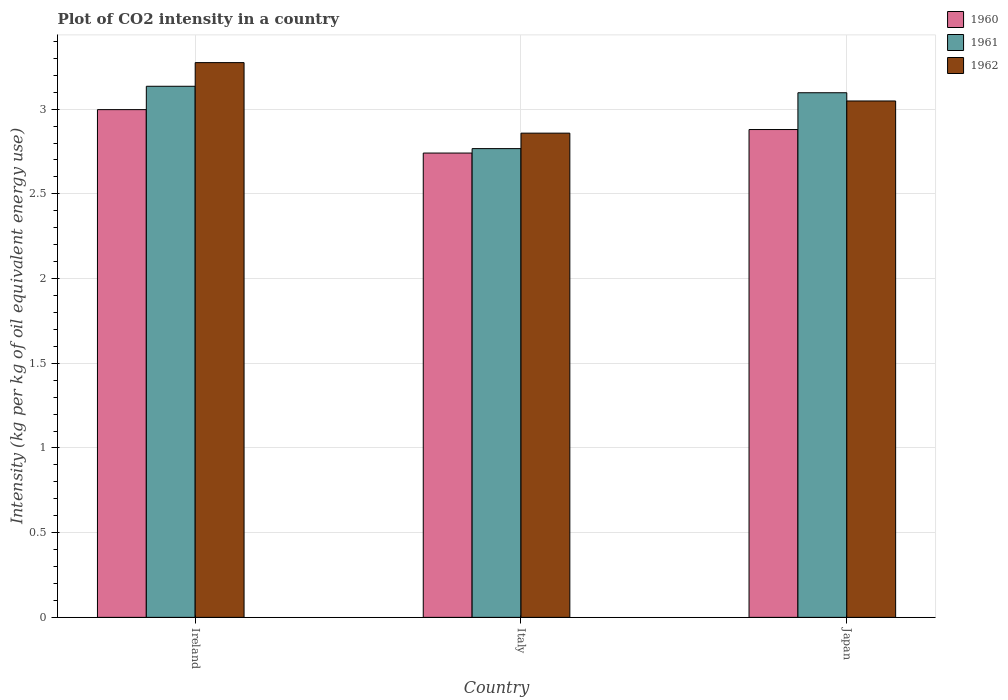How many different coloured bars are there?
Your answer should be very brief. 3. How many groups of bars are there?
Make the answer very short. 3. Are the number of bars per tick equal to the number of legend labels?
Keep it short and to the point. Yes. How many bars are there on the 3rd tick from the right?
Offer a very short reply. 3. What is the label of the 1st group of bars from the left?
Your answer should be compact. Ireland. In how many cases, is the number of bars for a given country not equal to the number of legend labels?
Offer a very short reply. 0. What is the CO2 intensity in in 1961 in Italy?
Keep it short and to the point. 2.77. Across all countries, what is the maximum CO2 intensity in in 1961?
Your response must be concise. 3.14. Across all countries, what is the minimum CO2 intensity in in 1960?
Ensure brevity in your answer.  2.74. In which country was the CO2 intensity in in 1960 maximum?
Your answer should be very brief. Ireland. In which country was the CO2 intensity in in 1961 minimum?
Ensure brevity in your answer.  Italy. What is the total CO2 intensity in in 1962 in the graph?
Ensure brevity in your answer.  9.18. What is the difference between the CO2 intensity in in 1960 in Ireland and that in Japan?
Ensure brevity in your answer.  0.12. What is the difference between the CO2 intensity in in 1960 in Ireland and the CO2 intensity in in 1962 in Italy?
Offer a very short reply. 0.14. What is the average CO2 intensity in in 1960 per country?
Offer a very short reply. 2.87. What is the difference between the CO2 intensity in of/in 1961 and CO2 intensity in of/in 1962 in Italy?
Ensure brevity in your answer.  -0.09. In how many countries, is the CO2 intensity in in 1961 greater than 1.8 kg?
Make the answer very short. 3. What is the ratio of the CO2 intensity in in 1961 in Italy to that in Japan?
Provide a succinct answer. 0.89. Is the difference between the CO2 intensity in in 1961 in Italy and Japan greater than the difference between the CO2 intensity in in 1962 in Italy and Japan?
Offer a very short reply. No. What is the difference between the highest and the second highest CO2 intensity in in 1962?
Provide a short and direct response. 0.19. What is the difference between the highest and the lowest CO2 intensity in in 1961?
Give a very brief answer. 0.37. In how many countries, is the CO2 intensity in in 1960 greater than the average CO2 intensity in in 1960 taken over all countries?
Make the answer very short. 2. Is the sum of the CO2 intensity in in 1960 in Ireland and Italy greater than the maximum CO2 intensity in in 1961 across all countries?
Keep it short and to the point. Yes. What does the 2nd bar from the right in Italy represents?
Ensure brevity in your answer.  1961. Is it the case that in every country, the sum of the CO2 intensity in in 1960 and CO2 intensity in in 1961 is greater than the CO2 intensity in in 1962?
Provide a succinct answer. Yes. Are all the bars in the graph horizontal?
Ensure brevity in your answer.  No. Does the graph contain any zero values?
Your response must be concise. No. Does the graph contain grids?
Your answer should be compact. Yes. How many legend labels are there?
Keep it short and to the point. 3. How are the legend labels stacked?
Offer a terse response. Vertical. What is the title of the graph?
Provide a short and direct response. Plot of CO2 intensity in a country. Does "1974" appear as one of the legend labels in the graph?
Offer a terse response. No. What is the label or title of the Y-axis?
Keep it short and to the point. Intensity (kg per kg of oil equivalent energy use). What is the Intensity (kg per kg of oil equivalent energy use) of 1960 in Ireland?
Your answer should be compact. 3. What is the Intensity (kg per kg of oil equivalent energy use) of 1961 in Ireland?
Ensure brevity in your answer.  3.14. What is the Intensity (kg per kg of oil equivalent energy use) of 1962 in Ireland?
Make the answer very short. 3.27. What is the Intensity (kg per kg of oil equivalent energy use) of 1960 in Italy?
Your answer should be compact. 2.74. What is the Intensity (kg per kg of oil equivalent energy use) of 1961 in Italy?
Provide a succinct answer. 2.77. What is the Intensity (kg per kg of oil equivalent energy use) of 1962 in Italy?
Your answer should be compact. 2.86. What is the Intensity (kg per kg of oil equivalent energy use) in 1960 in Japan?
Your response must be concise. 2.88. What is the Intensity (kg per kg of oil equivalent energy use) of 1961 in Japan?
Offer a very short reply. 3.1. What is the Intensity (kg per kg of oil equivalent energy use) in 1962 in Japan?
Offer a very short reply. 3.05. Across all countries, what is the maximum Intensity (kg per kg of oil equivalent energy use) of 1960?
Your answer should be very brief. 3. Across all countries, what is the maximum Intensity (kg per kg of oil equivalent energy use) of 1961?
Your answer should be compact. 3.14. Across all countries, what is the maximum Intensity (kg per kg of oil equivalent energy use) in 1962?
Provide a succinct answer. 3.27. Across all countries, what is the minimum Intensity (kg per kg of oil equivalent energy use) in 1960?
Provide a succinct answer. 2.74. Across all countries, what is the minimum Intensity (kg per kg of oil equivalent energy use) in 1961?
Your answer should be compact. 2.77. Across all countries, what is the minimum Intensity (kg per kg of oil equivalent energy use) of 1962?
Keep it short and to the point. 2.86. What is the total Intensity (kg per kg of oil equivalent energy use) of 1960 in the graph?
Offer a terse response. 8.62. What is the total Intensity (kg per kg of oil equivalent energy use) of 1961 in the graph?
Give a very brief answer. 9. What is the total Intensity (kg per kg of oil equivalent energy use) of 1962 in the graph?
Provide a succinct answer. 9.18. What is the difference between the Intensity (kg per kg of oil equivalent energy use) of 1960 in Ireland and that in Italy?
Make the answer very short. 0.26. What is the difference between the Intensity (kg per kg of oil equivalent energy use) of 1961 in Ireland and that in Italy?
Make the answer very short. 0.37. What is the difference between the Intensity (kg per kg of oil equivalent energy use) in 1962 in Ireland and that in Italy?
Your response must be concise. 0.42. What is the difference between the Intensity (kg per kg of oil equivalent energy use) in 1960 in Ireland and that in Japan?
Provide a short and direct response. 0.12. What is the difference between the Intensity (kg per kg of oil equivalent energy use) of 1961 in Ireland and that in Japan?
Provide a short and direct response. 0.04. What is the difference between the Intensity (kg per kg of oil equivalent energy use) in 1962 in Ireland and that in Japan?
Give a very brief answer. 0.23. What is the difference between the Intensity (kg per kg of oil equivalent energy use) in 1960 in Italy and that in Japan?
Offer a terse response. -0.14. What is the difference between the Intensity (kg per kg of oil equivalent energy use) in 1961 in Italy and that in Japan?
Your answer should be very brief. -0.33. What is the difference between the Intensity (kg per kg of oil equivalent energy use) of 1962 in Italy and that in Japan?
Offer a terse response. -0.19. What is the difference between the Intensity (kg per kg of oil equivalent energy use) in 1960 in Ireland and the Intensity (kg per kg of oil equivalent energy use) in 1961 in Italy?
Offer a very short reply. 0.23. What is the difference between the Intensity (kg per kg of oil equivalent energy use) in 1960 in Ireland and the Intensity (kg per kg of oil equivalent energy use) in 1962 in Italy?
Your answer should be compact. 0.14. What is the difference between the Intensity (kg per kg of oil equivalent energy use) in 1961 in Ireland and the Intensity (kg per kg of oil equivalent energy use) in 1962 in Italy?
Offer a terse response. 0.28. What is the difference between the Intensity (kg per kg of oil equivalent energy use) in 1960 in Ireland and the Intensity (kg per kg of oil equivalent energy use) in 1961 in Japan?
Provide a succinct answer. -0.1. What is the difference between the Intensity (kg per kg of oil equivalent energy use) of 1960 in Ireland and the Intensity (kg per kg of oil equivalent energy use) of 1962 in Japan?
Your response must be concise. -0.05. What is the difference between the Intensity (kg per kg of oil equivalent energy use) in 1961 in Ireland and the Intensity (kg per kg of oil equivalent energy use) in 1962 in Japan?
Your answer should be very brief. 0.09. What is the difference between the Intensity (kg per kg of oil equivalent energy use) in 1960 in Italy and the Intensity (kg per kg of oil equivalent energy use) in 1961 in Japan?
Your answer should be very brief. -0.36. What is the difference between the Intensity (kg per kg of oil equivalent energy use) in 1960 in Italy and the Intensity (kg per kg of oil equivalent energy use) in 1962 in Japan?
Your response must be concise. -0.31. What is the difference between the Intensity (kg per kg of oil equivalent energy use) of 1961 in Italy and the Intensity (kg per kg of oil equivalent energy use) of 1962 in Japan?
Your answer should be compact. -0.28. What is the average Intensity (kg per kg of oil equivalent energy use) in 1960 per country?
Provide a succinct answer. 2.87. What is the average Intensity (kg per kg of oil equivalent energy use) of 1961 per country?
Offer a very short reply. 3. What is the average Intensity (kg per kg of oil equivalent energy use) of 1962 per country?
Your response must be concise. 3.06. What is the difference between the Intensity (kg per kg of oil equivalent energy use) in 1960 and Intensity (kg per kg of oil equivalent energy use) in 1961 in Ireland?
Make the answer very short. -0.14. What is the difference between the Intensity (kg per kg of oil equivalent energy use) of 1960 and Intensity (kg per kg of oil equivalent energy use) of 1962 in Ireland?
Keep it short and to the point. -0.28. What is the difference between the Intensity (kg per kg of oil equivalent energy use) of 1961 and Intensity (kg per kg of oil equivalent energy use) of 1962 in Ireland?
Provide a succinct answer. -0.14. What is the difference between the Intensity (kg per kg of oil equivalent energy use) of 1960 and Intensity (kg per kg of oil equivalent energy use) of 1961 in Italy?
Offer a terse response. -0.03. What is the difference between the Intensity (kg per kg of oil equivalent energy use) in 1960 and Intensity (kg per kg of oil equivalent energy use) in 1962 in Italy?
Make the answer very short. -0.12. What is the difference between the Intensity (kg per kg of oil equivalent energy use) in 1961 and Intensity (kg per kg of oil equivalent energy use) in 1962 in Italy?
Provide a short and direct response. -0.09. What is the difference between the Intensity (kg per kg of oil equivalent energy use) of 1960 and Intensity (kg per kg of oil equivalent energy use) of 1961 in Japan?
Provide a succinct answer. -0.22. What is the difference between the Intensity (kg per kg of oil equivalent energy use) of 1960 and Intensity (kg per kg of oil equivalent energy use) of 1962 in Japan?
Your answer should be compact. -0.17. What is the difference between the Intensity (kg per kg of oil equivalent energy use) in 1961 and Intensity (kg per kg of oil equivalent energy use) in 1962 in Japan?
Your response must be concise. 0.05. What is the ratio of the Intensity (kg per kg of oil equivalent energy use) in 1960 in Ireland to that in Italy?
Your answer should be very brief. 1.09. What is the ratio of the Intensity (kg per kg of oil equivalent energy use) of 1961 in Ireland to that in Italy?
Provide a succinct answer. 1.13. What is the ratio of the Intensity (kg per kg of oil equivalent energy use) in 1962 in Ireland to that in Italy?
Give a very brief answer. 1.15. What is the ratio of the Intensity (kg per kg of oil equivalent energy use) in 1960 in Ireland to that in Japan?
Provide a succinct answer. 1.04. What is the ratio of the Intensity (kg per kg of oil equivalent energy use) of 1961 in Ireland to that in Japan?
Make the answer very short. 1.01. What is the ratio of the Intensity (kg per kg of oil equivalent energy use) in 1962 in Ireland to that in Japan?
Keep it short and to the point. 1.07. What is the ratio of the Intensity (kg per kg of oil equivalent energy use) of 1960 in Italy to that in Japan?
Keep it short and to the point. 0.95. What is the ratio of the Intensity (kg per kg of oil equivalent energy use) in 1961 in Italy to that in Japan?
Provide a short and direct response. 0.89. What is the ratio of the Intensity (kg per kg of oil equivalent energy use) in 1962 in Italy to that in Japan?
Offer a terse response. 0.94. What is the difference between the highest and the second highest Intensity (kg per kg of oil equivalent energy use) in 1960?
Keep it short and to the point. 0.12. What is the difference between the highest and the second highest Intensity (kg per kg of oil equivalent energy use) of 1961?
Offer a terse response. 0.04. What is the difference between the highest and the second highest Intensity (kg per kg of oil equivalent energy use) in 1962?
Your answer should be compact. 0.23. What is the difference between the highest and the lowest Intensity (kg per kg of oil equivalent energy use) in 1960?
Give a very brief answer. 0.26. What is the difference between the highest and the lowest Intensity (kg per kg of oil equivalent energy use) in 1961?
Make the answer very short. 0.37. What is the difference between the highest and the lowest Intensity (kg per kg of oil equivalent energy use) in 1962?
Your answer should be compact. 0.42. 